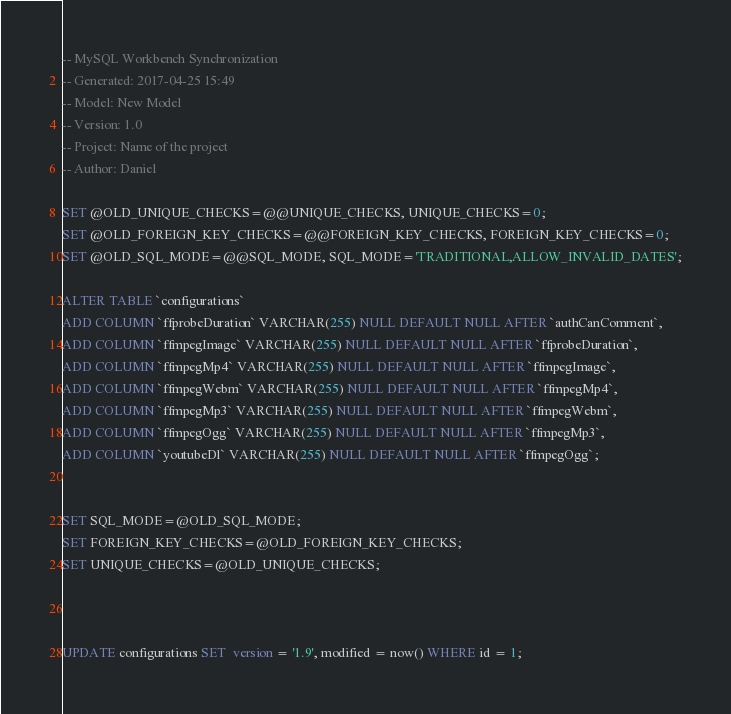Convert code to text. <code><loc_0><loc_0><loc_500><loc_500><_SQL_>-- MySQL Workbench Synchronization
-- Generated: 2017-04-25 15:49
-- Model: New Model
-- Version: 1.0
-- Project: Name of the project
-- Author: Daniel

SET @OLD_UNIQUE_CHECKS=@@UNIQUE_CHECKS, UNIQUE_CHECKS=0;
SET @OLD_FOREIGN_KEY_CHECKS=@@FOREIGN_KEY_CHECKS, FOREIGN_KEY_CHECKS=0;
SET @OLD_SQL_MODE=@@SQL_MODE, SQL_MODE='TRADITIONAL,ALLOW_INVALID_DATES';

ALTER TABLE `configurations` 
ADD COLUMN `ffprobeDuration` VARCHAR(255) NULL DEFAULT NULL AFTER `authCanComment`,
ADD COLUMN `ffmpegImage` VARCHAR(255) NULL DEFAULT NULL AFTER `ffprobeDuration`,
ADD COLUMN `ffmpegMp4` VARCHAR(255) NULL DEFAULT NULL AFTER `ffmpegImage`,
ADD COLUMN `ffmpegWebm` VARCHAR(255) NULL DEFAULT NULL AFTER `ffmpegMp4`,
ADD COLUMN `ffmpegMp3` VARCHAR(255) NULL DEFAULT NULL AFTER `ffmpegWebm`,
ADD COLUMN `ffmpegOgg` VARCHAR(255) NULL DEFAULT NULL AFTER `ffmpegMp3`,
ADD COLUMN `youtubeDl` VARCHAR(255) NULL DEFAULT NULL AFTER `ffmpegOgg`;


SET SQL_MODE=@OLD_SQL_MODE;
SET FOREIGN_KEY_CHECKS=@OLD_FOREIGN_KEY_CHECKS;
SET UNIQUE_CHECKS=@OLD_UNIQUE_CHECKS;



UPDATE configurations SET  version = '1.9', modified = now() WHERE id = 1;</code> 